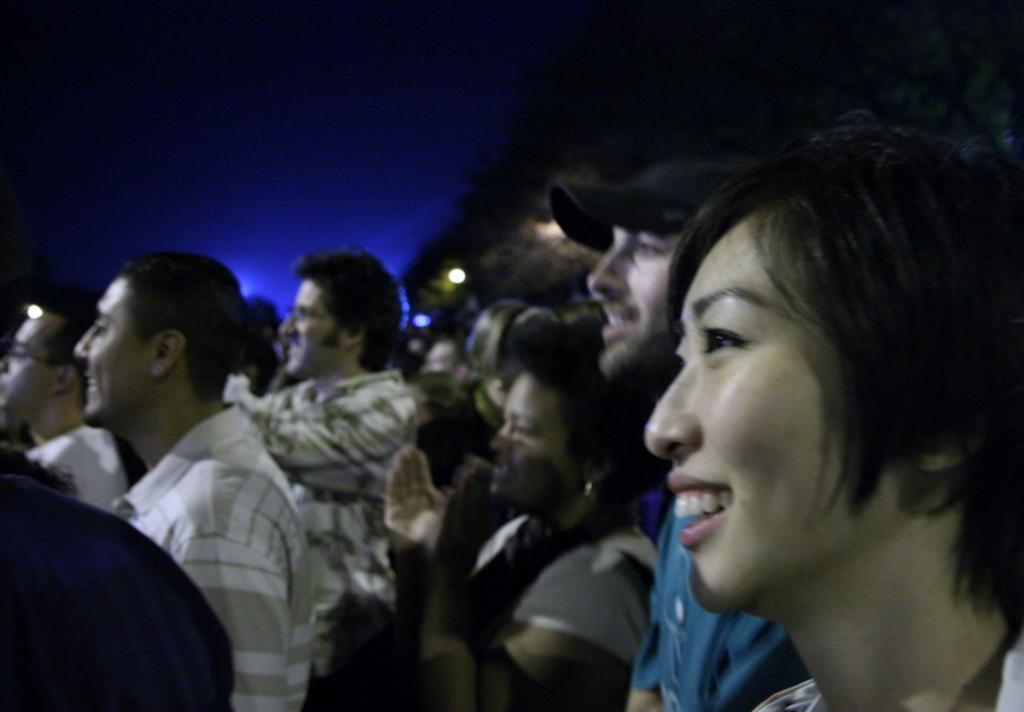How many people are in the image? There is a group of people in the image. Can you describe any specific clothing item worn by one of the people? One person is wearing a cap. What can be seen in the background of the image? There are lights, a tree, and the sky visible in the background. What type of bear can be seen interacting with the group of people in the image? There is no bear present in the image; it features a group of people and various background elements. How is the glue being used by the people in the image? There is no glue present in the image, so it cannot be determined how it might be used. 